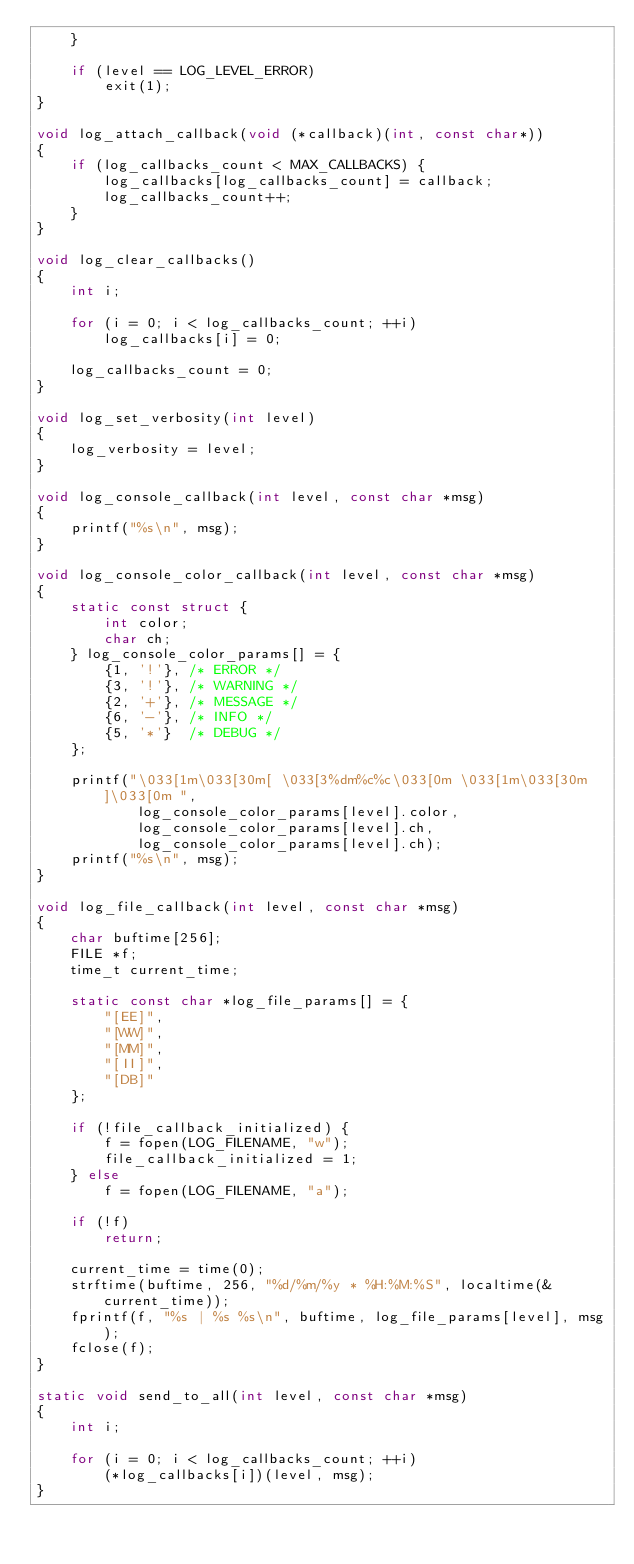<code> <loc_0><loc_0><loc_500><loc_500><_C_>	}

	if (level == LOG_LEVEL_ERROR)	
		exit(1);
}

void log_attach_callback(void (*callback)(int, const char*))
{
	if (log_callbacks_count < MAX_CALLBACKS) {
		log_callbacks[log_callbacks_count] = callback;
		log_callbacks_count++;
	}
}

void log_clear_callbacks()
{
	int i;

	for (i = 0; i < log_callbacks_count; ++i)
		log_callbacks[i] = 0;

	log_callbacks_count = 0;
}

void log_set_verbosity(int level)
{
	log_verbosity = level;
}

void log_console_callback(int level, const char *msg)
{
	printf("%s\n", msg);
}

void log_console_color_callback(int level, const char *msg)
{
	static const struct { 
		int color; 
		char ch; 
	} log_console_color_params[] = {
		{1, '!'}, /* ERROR */
		{3, '!'}, /* WARNING */
		{2, '+'}, /* MESSAGE */
		{6, '-'}, /* INFO */
		{5, '*'}  /* DEBUG */
	};
	
	printf("\033[1m\033[30m[ \033[3%dm%c%c\033[0m \033[1m\033[30m]\033[0m ",
			log_console_color_params[level].color,
			log_console_color_params[level].ch,
			log_console_color_params[level].ch);
	printf("%s\n", msg);
}

void log_file_callback(int level, const char *msg)
{
	char buftime[256];
	FILE *f;
	time_t current_time;

	static const char *log_file_params[] = {
		"[EE]",
		"[WW]",
		"[MM]",
		"[II]",
		"[DB]"
	};

	if (!file_callback_initialized) {
		f = fopen(LOG_FILENAME, "w");
		file_callback_initialized = 1;
	} else
		f = fopen(LOG_FILENAME, "a");

	if (!f) 
		return;

	current_time = time(0);
	strftime(buftime, 256, "%d/%m/%y * %H:%M:%S", localtime(&current_time));
	fprintf(f, "%s | %s %s\n", buftime, log_file_params[level], msg);	
	fclose(f);
}

static void send_to_all(int level, const char *msg)
{
	int i;

	for (i = 0; i < log_callbacks_count; ++i)
		(*log_callbacks[i])(level, msg);
}

</code> 